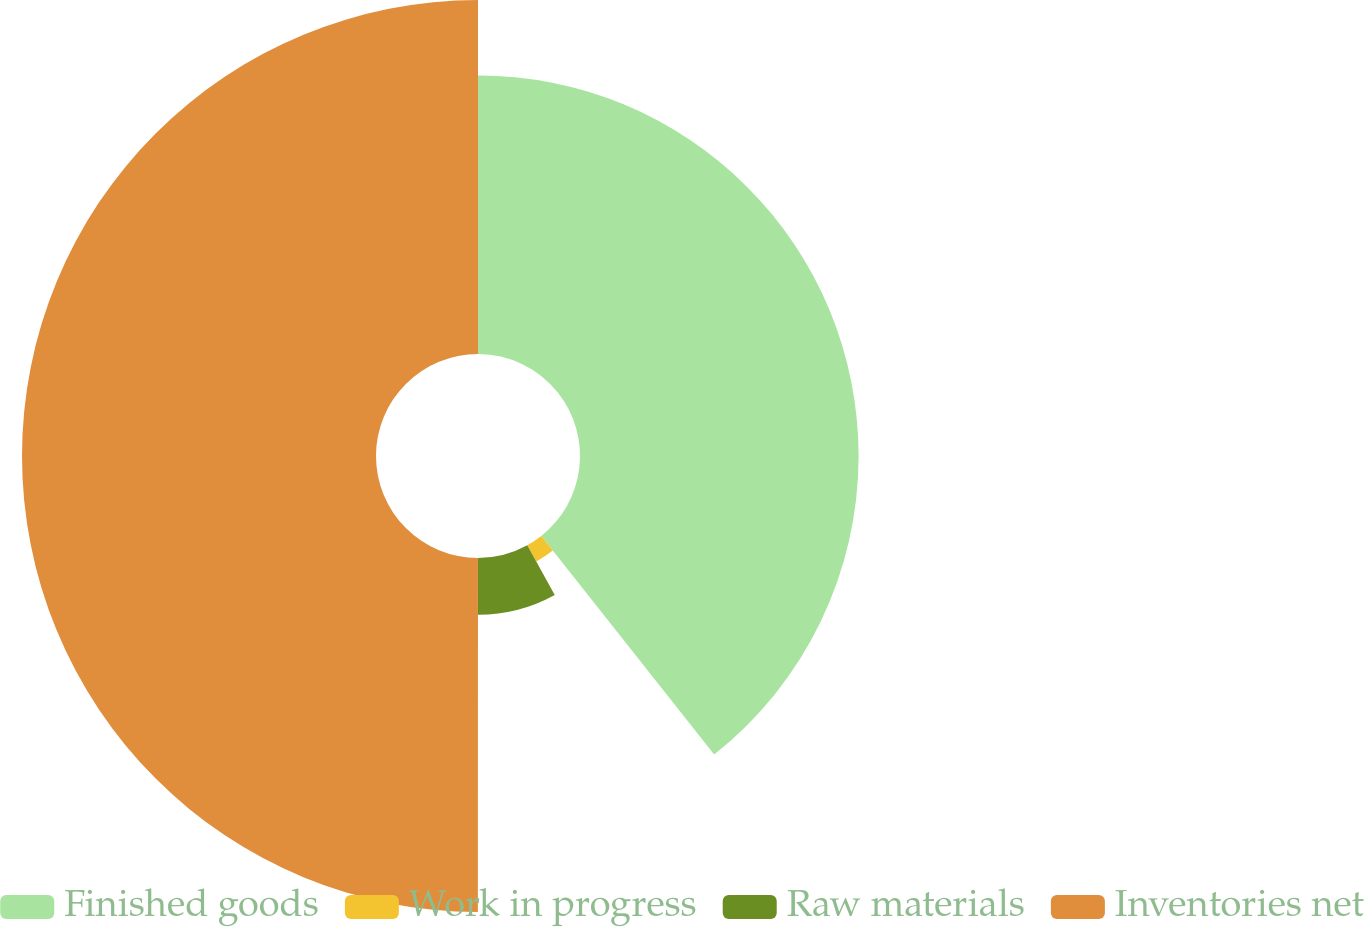Convert chart. <chart><loc_0><loc_0><loc_500><loc_500><pie_chart><fcel>Finished goods<fcel>Work in progress<fcel>Raw materials<fcel>Inventories net<nl><fcel>39.35%<fcel>2.63%<fcel>8.03%<fcel>50.0%<nl></chart> 